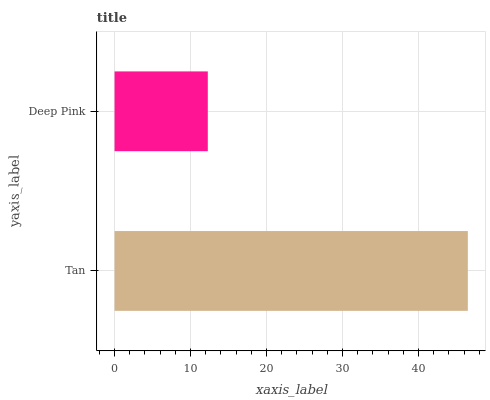Is Deep Pink the minimum?
Answer yes or no. Yes. Is Tan the maximum?
Answer yes or no. Yes. Is Deep Pink the maximum?
Answer yes or no. No. Is Tan greater than Deep Pink?
Answer yes or no. Yes. Is Deep Pink less than Tan?
Answer yes or no. Yes. Is Deep Pink greater than Tan?
Answer yes or no. No. Is Tan less than Deep Pink?
Answer yes or no. No. Is Tan the high median?
Answer yes or no. Yes. Is Deep Pink the low median?
Answer yes or no. Yes. Is Deep Pink the high median?
Answer yes or no. No. Is Tan the low median?
Answer yes or no. No. 